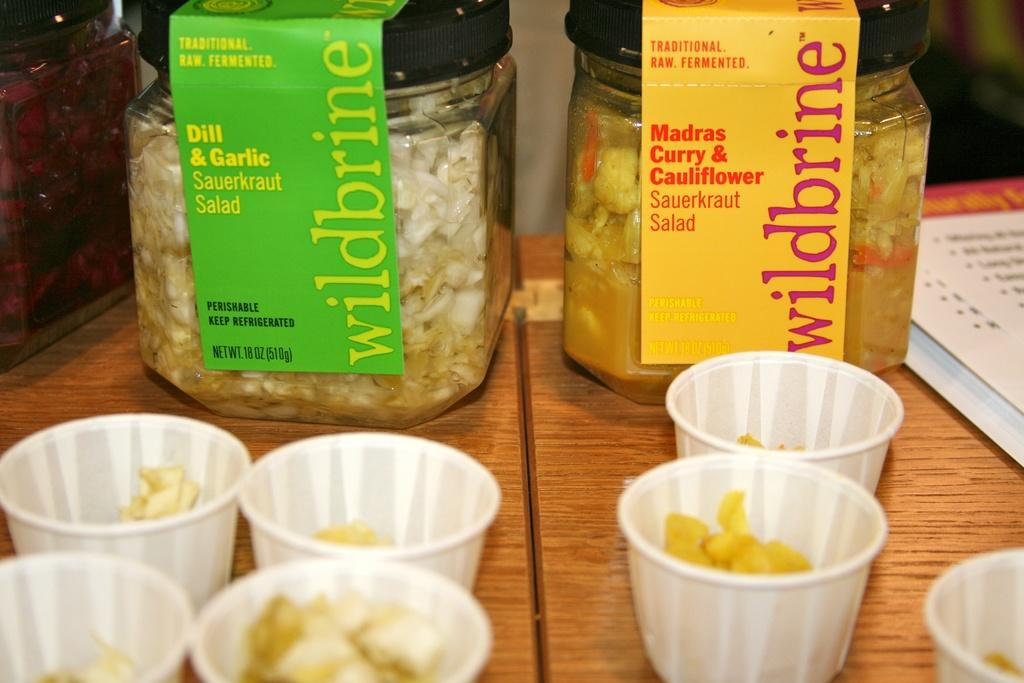What is the main piece of furniture in the image? There is a table in the image. What can be found on the table? There are two jars filled with food items and a menu card on the table. Are there any other items related to food on the table? Yes, there are cups with food items in front of the jars. How many walls can be seen in the image? There is no information about walls in the image, as it only shows a table with jars, a menu card, and cups. 